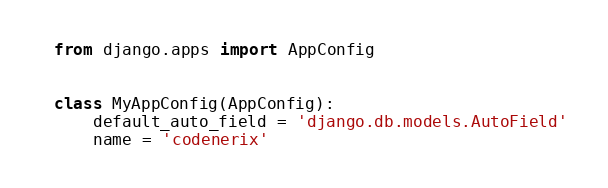Convert code to text. <code><loc_0><loc_0><loc_500><loc_500><_Python_>from django.apps import AppConfig


class MyAppConfig(AppConfig):
    default_auto_field = 'django.db.models.AutoField'
    name = 'codenerix'
</code> 